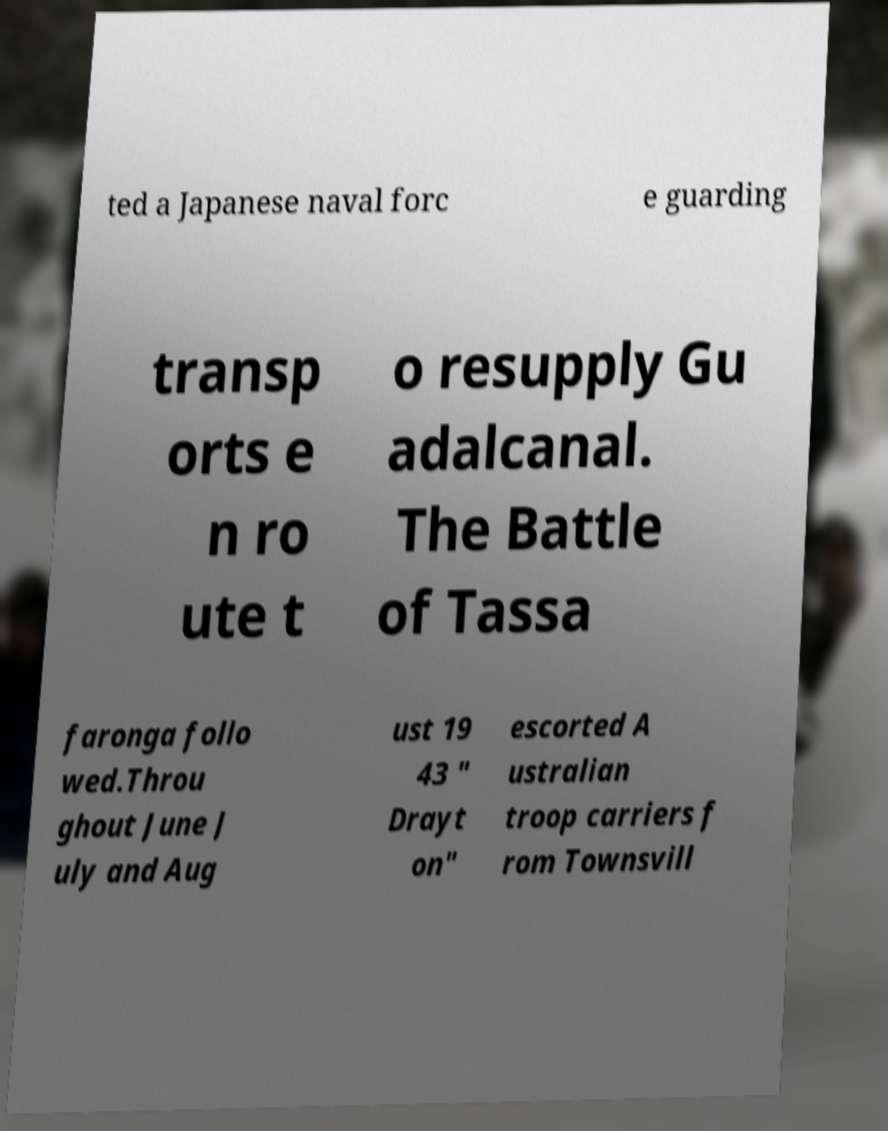There's text embedded in this image that I need extracted. Can you transcribe it verbatim? ted a Japanese naval forc e guarding transp orts e n ro ute t o resupply Gu adalcanal. The Battle of Tassa faronga follo wed.Throu ghout June J uly and Aug ust 19 43 " Drayt on" escorted A ustralian troop carriers f rom Townsvill 